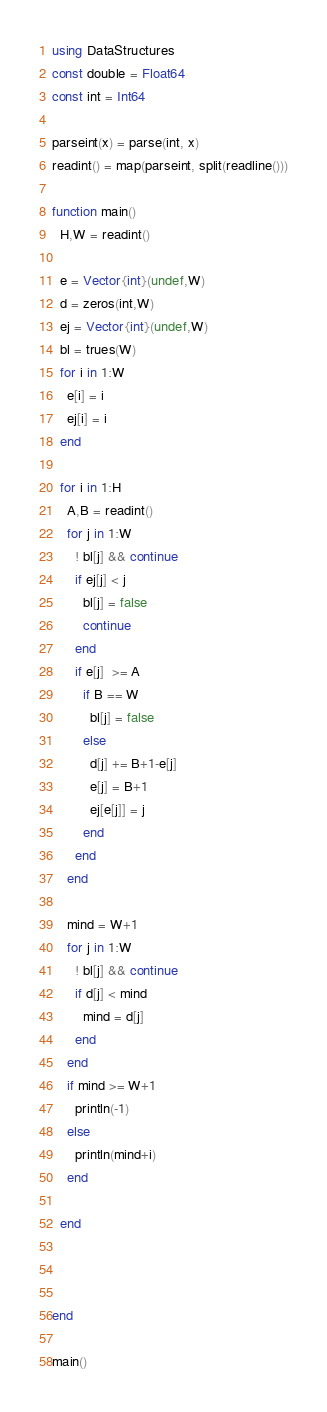<code> <loc_0><loc_0><loc_500><loc_500><_Julia_>using DataStructures
const double = Float64
const int = Int64

parseint(x) = parse(int, x)
readint() = map(parseint, split(readline()))

function main()
  H,W = readint() 

  e = Vector{int}(undef,W)
  d = zeros(int,W)
  ej = Vector{int}(undef,W)
  bl = trues(W)
  for i in 1:W
    e[i] = i
    ej[i] = i
  end

  for i in 1:H
    A,B = readint()
    for j in 1:W
      ! bl[j] && continue
      if ej[j] < j
        bl[j] = false
        continue
      end
      if e[j]  >= A
        if B == W
          bl[j] = false
        else 
          d[j] += B+1-e[j]
          e[j] = B+1
          ej[e[j]] = j
        end
      end 
    end
    
    mind = W+1
    for j in 1:W
      ! bl[j] && continue
      if d[j] < mind
        mind = d[j]
      end
    end
    if mind >= W+1 
      println(-1)
    else
      println(mind+i)
    end

  end
  
  

end

main()
</code> 